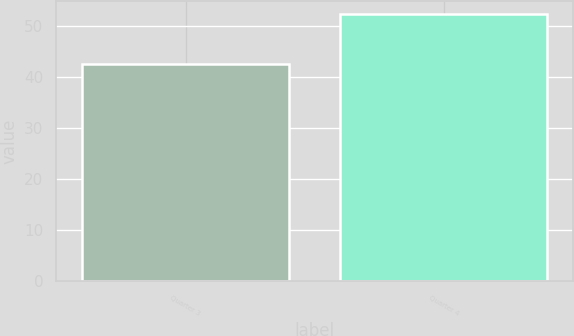<chart> <loc_0><loc_0><loc_500><loc_500><bar_chart><fcel>Quarter 3<fcel>Quarter 4<nl><fcel>42.6<fcel>52.36<nl></chart> 